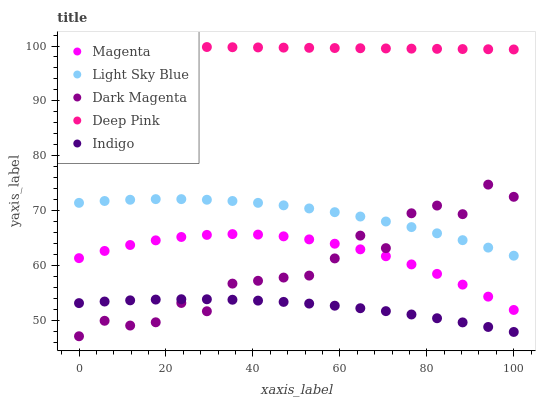Does Indigo have the minimum area under the curve?
Answer yes or no. Yes. Does Deep Pink have the maximum area under the curve?
Answer yes or no. Yes. Does Light Sky Blue have the minimum area under the curve?
Answer yes or no. No. Does Light Sky Blue have the maximum area under the curve?
Answer yes or no. No. Is Deep Pink the smoothest?
Answer yes or no. Yes. Is Dark Magenta the roughest?
Answer yes or no. Yes. Is Light Sky Blue the smoothest?
Answer yes or no. No. Is Light Sky Blue the roughest?
Answer yes or no. No. Does Dark Magenta have the lowest value?
Answer yes or no. Yes. Does Light Sky Blue have the lowest value?
Answer yes or no. No. Does Deep Pink have the highest value?
Answer yes or no. Yes. Does Light Sky Blue have the highest value?
Answer yes or no. No. Is Dark Magenta less than Deep Pink?
Answer yes or no. Yes. Is Light Sky Blue greater than Indigo?
Answer yes or no. Yes. Does Dark Magenta intersect Light Sky Blue?
Answer yes or no. Yes. Is Dark Magenta less than Light Sky Blue?
Answer yes or no. No. Is Dark Magenta greater than Light Sky Blue?
Answer yes or no. No. Does Dark Magenta intersect Deep Pink?
Answer yes or no. No. 